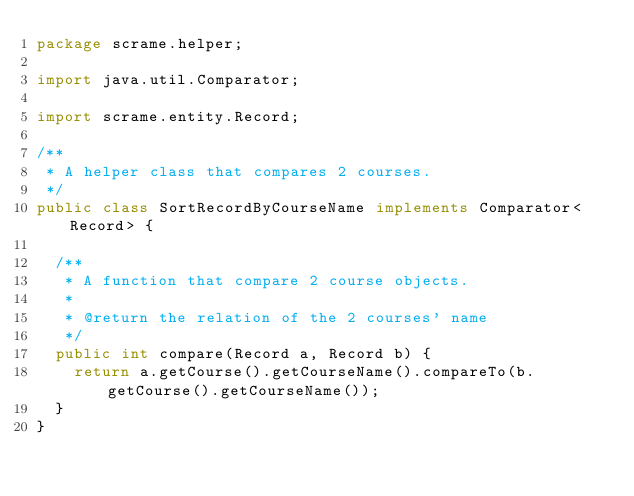Convert code to text. <code><loc_0><loc_0><loc_500><loc_500><_Java_>package scrame.helper;

import java.util.Comparator;

import scrame.entity.Record;

/**
 * A helper class that compares 2 courses.
 */
public class SortRecordByCourseName implements Comparator<Record> {

  /**
   * A function that compare 2 course objects.
   * 
   * @return the relation of the 2 courses' name
   */
  public int compare(Record a, Record b) {
    return a.getCourse().getCourseName().compareTo(b.getCourse().getCourseName());
  }
}
</code> 